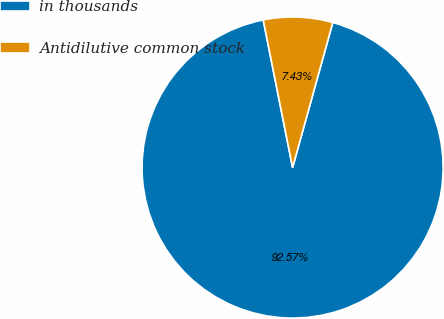Convert chart. <chart><loc_0><loc_0><loc_500><loc_500><pie_chart><fcel>in thousands<fcel>Antidilutive common stock<nl><fcel>92.57%<fcel>7.43%<nl></chart> 